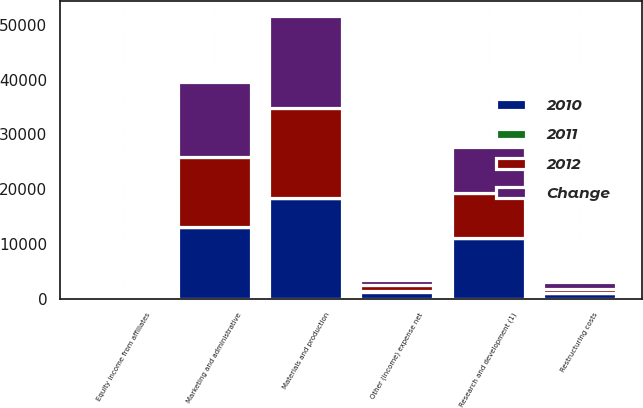Convert chart. <chart><loc_0><loc_0><loc_500><loc_500><stacked_bar_chart><ecel><fcel>Materials and production<fcel>Marketing and administrative<fcel>Research and development (1)<fcel>Restructuring costs<fcel>Equity income from affiliates<fcel>Other (income) expense net<nl><fcel>2012<fcel>16446<fcel>12776<fcel>8168<fcel>664<fcel>642<fcel>1116<nl><fcel>2011<fcel>3<fcel>7<fcel>4<fcel>49<fcel>5<fcel>18<nl><fcel>Change<fcel>16871<fcel>13733<fcel>8467<fcel>1306<fcel>610<fcel>946<nl><fcel>2010<fcel>18396<fcel>13125<fcel>11111<fcel>985<fcel>587<fcel>1304<nl></chart> 